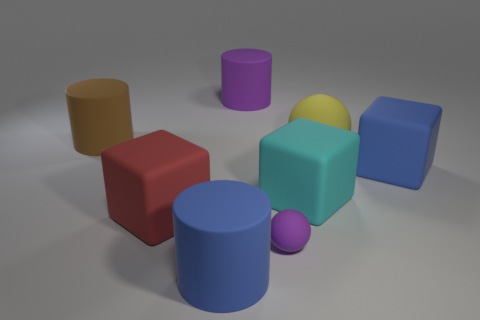Add 1 large yellow matte objects. How many objects exist? 9 Subtract all purple cylinders. How many cylinders are left? 2 Subtract all spheres. How many objects are left? 6 Subtract all yellow spheres. How many spheres are left? 1 Subtract 3 cubes. How many cubes are left? 0 Add 4 large balls. How many large balls are left? 5 Add 8 tiny purple rubber balls. How many tiny purple rubber balls exist? 9 Subtract 0 green blocks. How many objects are left? 8 Subtract all purple balls. Subtract all cyan cubes. How many balls are left? 1 Subtract all red cubes. How many yellow spheres are left? 1 